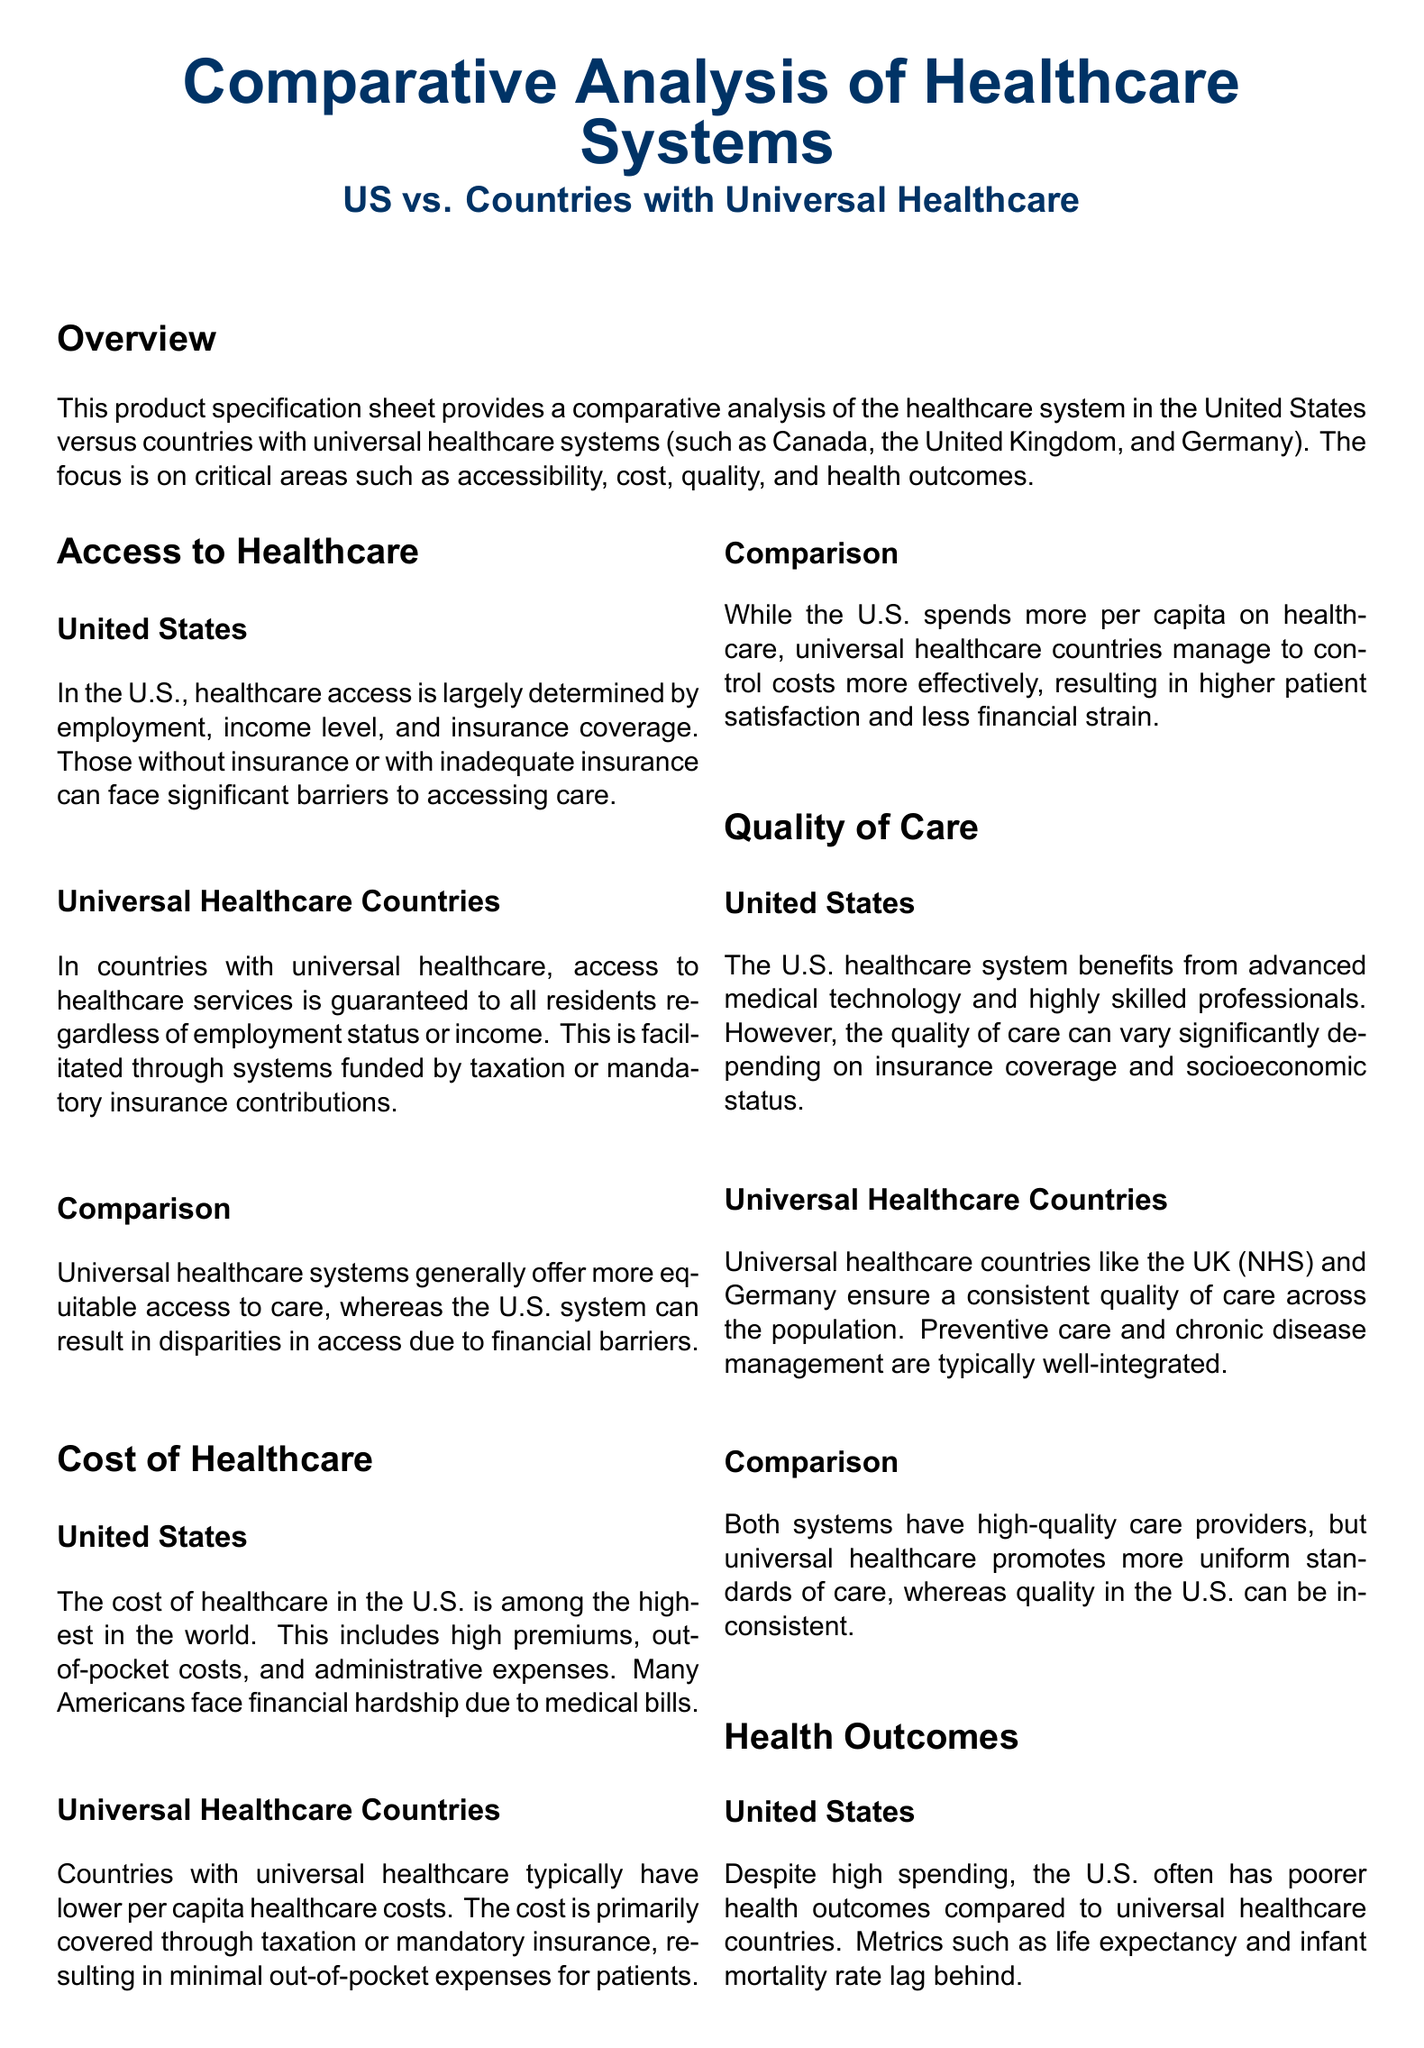What are the criteria for access to healthcare in the United States? The criteria are largely determined by employment, income level, and insurance coverage.
Answer: Employment, income level, and insurance coverage How do universal healthcare systems ensure access to services? Access is guaranteed to all residents regardless of employment status or income, funded by taxation or mandatory insurance contributions.
Answer: Taxation or mandatory insurance contributions What is a significant financial burden experienced by many Americans concerning healthcare? Many Americans face financial hardship due to medical bills.
Answer: Medical bills How does the cost of healthcare in universal healthcare countries compare to the U.S.? Countries with universal healthcare typically have lower per capita healthcare costs.
Answer: Lower per capita healthcare costs What aspect of healthcare does the U.S. system vary significantly by? The quality of care can vary significantly depending on insurance coverage and socioeconomic status.
Answer: Insurance coverage and socioeconomic status Which country is specifically mentioned as having a universal healthcare system? The UK (NHS) is mentioned as an example of a universal healthcare country.
Answer: UK (NHS) What health metric do universal healthcare countries generally exhibit better results in compared to the U.S.? They generally have higher life expectancy.
Answer: Higher life expectancy What is a notable conclusion about the U.S. healthcare system? The U.S. healthcare system is often less accessible and more expensive compared to universal healthcare systems.
Answer: Less accessible and more expensive How does the document categorize the sections of the healthcare analysis? The sections are categorized into Access to Healthcare, Cost of Healthcare, Quality of Care, and Health Outcomes.
Answer: Access to Healthcare, Cost of Healthcare, Quality of Care, Health Outcomes 